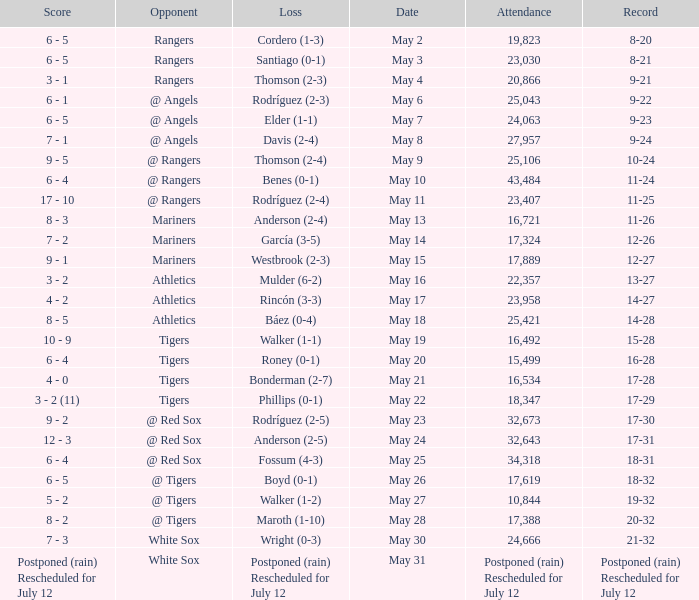What date did the Indians have a record of 14-28? May 18. 